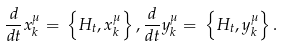<formula> <loc_0><loc_0><loc_500><loc_500>\frac { d } { d t } x ^ { \mu } _ { k } = \, \left \{ H _ { t } , x ^ { \mu } _ { k } \right \} , \frac { d } { d t } y ^ { \mu } _ { k } = \, \left \{ H _ { t } , y ^ { \mu } _ { k } \right \} .</formula> 